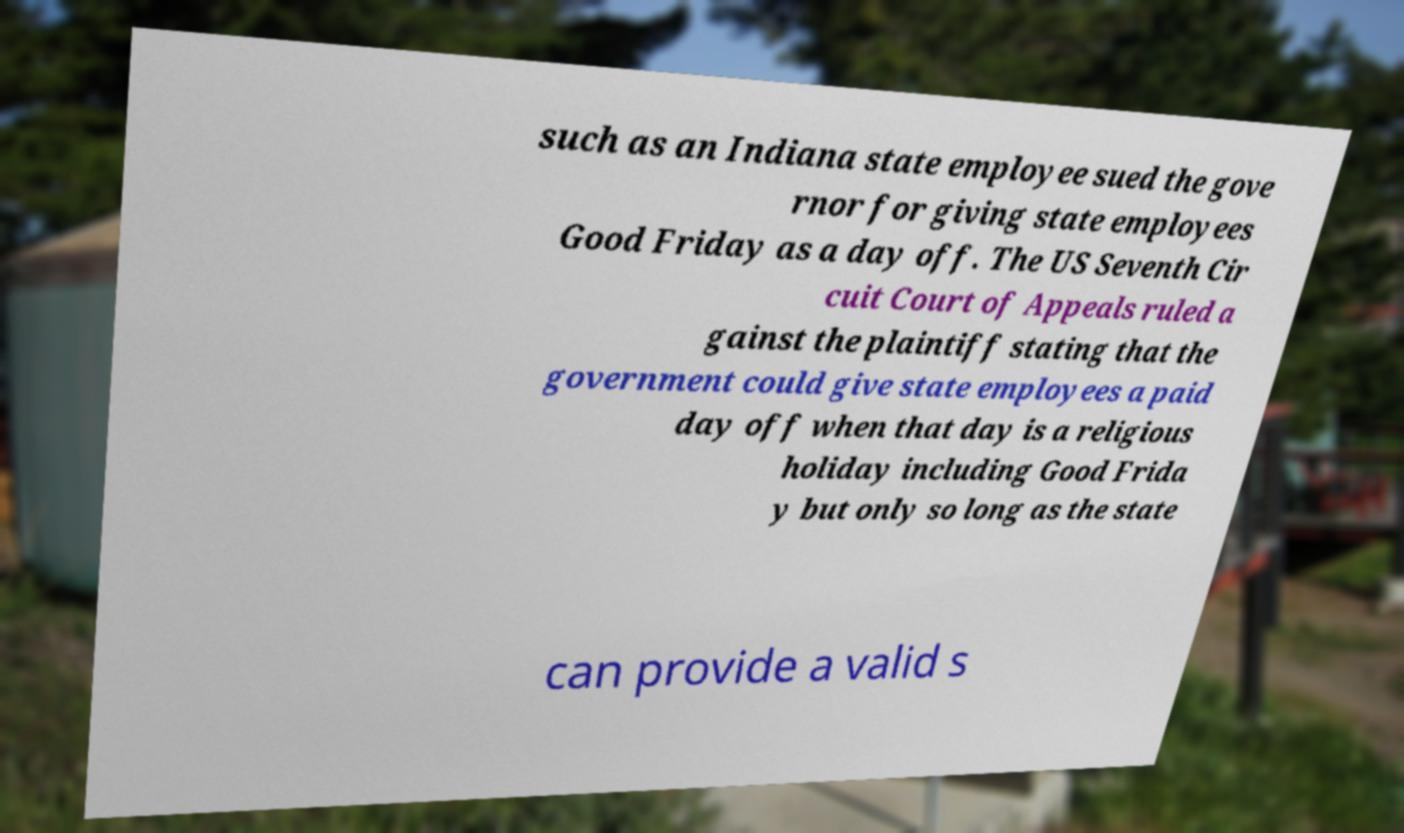Please read and relay the text visible in this image. What does it say? such as an Indiana state employee sued the gove rnor for giving state employees Good Friday as a day off. The US Seventh Cir cuit Court of Appeals ruled a gainst the plaintiff stating that the government could give state employees a paid day off when that day is a religious holiday including Good Frida y but only so long as the state can provide a valid s 